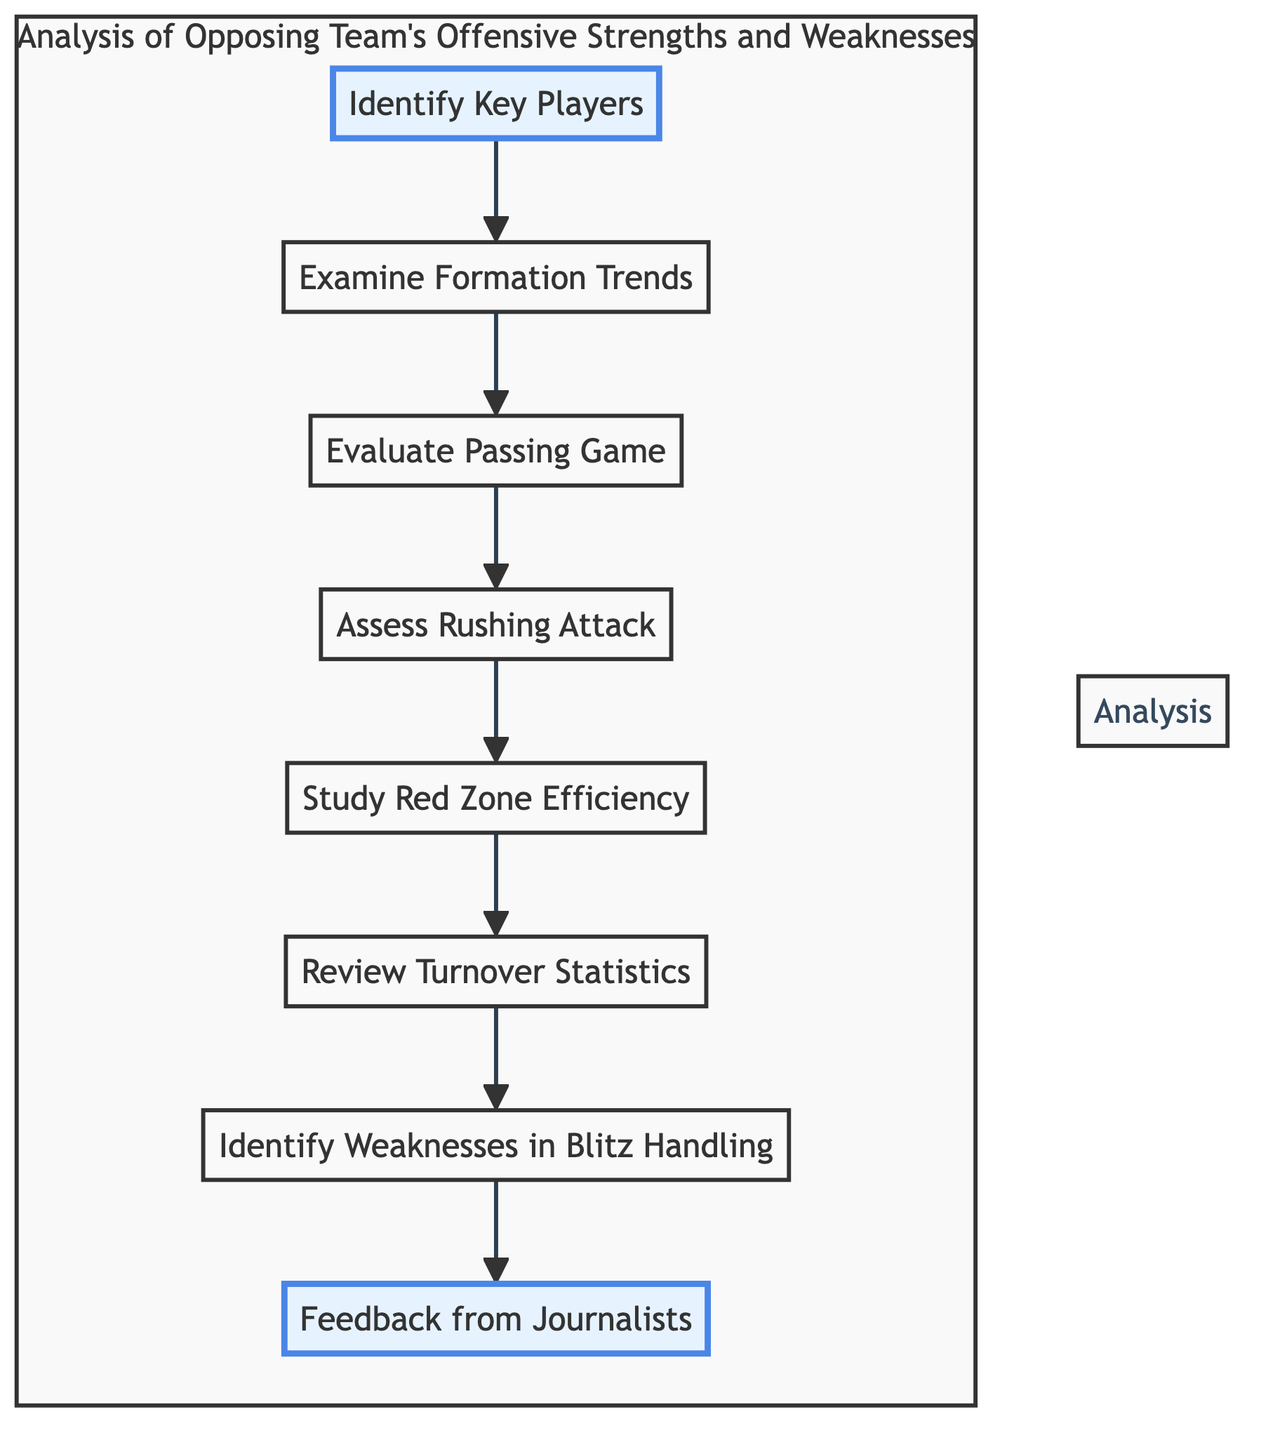What is the first step in the analysis? The first step in the flowchart is "Identify Key Players," which is the starting node that initiates the analysis process.
Answer: Identify Key Players How many total nodes are present in this flowchart? There are eight nodes in total, each representing a specific step in the analysis of the opposing team's offensive strengths and weaknesses.
Answer: Eight Which node follows "Evaluate Passing Game"? The node that follows "Evaluate Passing Game" is "Assess Rushing Attack." This shows the flow of analysis from one aspect of the offense to another.
Answer: Assess Rushing Attack What do "Review Turnover Statistics" and "Identify Weaknesses in Blitz Handling" have in common? Both nodes represent steps in the analysis process that focus on the potential vulnerabilities of the opposing offense, with the latter specifically addressing how they handle defensive pressure.
Answer: Potential vulnerabilities What is the last node in the flowchart? The last node in the flowchart is "Feedback from Journalists," which concludes the analysis process by incorporating external insights.
Answer: Feedback from Journalists Which two nodes are highlighted in the flowchart? The two highlighted nodes are "Identify Key Players" and "Feedback from Journalists," indicating their significance within the analysis process.
Answer: Identify Key Players and Feedback from Journalists If "Study Red Zone Efficiency" is addressed, which node precedes it? The node that precedes "Study Red Zone Efficiency" is "Assess Rushing Attack," showing the sequential nature of the analysis approach.
Answer: Assess Rushing Attack How does the flowchart indicate the steps in the analysis? The flowchart uses directed arrows to show the progression from one analysis step to the next, visually illustrating the sequence of actions taken.
Answer: Directed arrows 